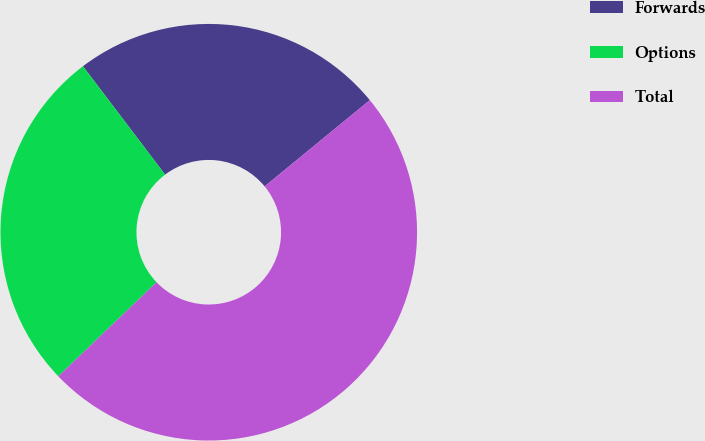Convert chart. <chart><loc_0><loc_0><loc_500><loc_500><pie_chart><fcel>Forwards<fcel>Options<fcel>Total<nl><fcel>24.39%<fcel>26.83%<fcel>48.78%<nl></chart> 